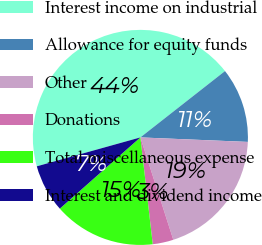<chart> <loc_0><loc_0><loc_500><loc_500><pie_chart><fcel>Interest income on industrial<fcel>Allowance for equity funds<fcel>Other<fcel>Donations<fcel>Total miscellaneous expense<fcel>Interest and dividend income<nl><fcel>43.75%<fcel>11.25%<fcel>19.38%<fcel>3.12%<fcel>15.31%<fcel>7.19%<nl></chart> 